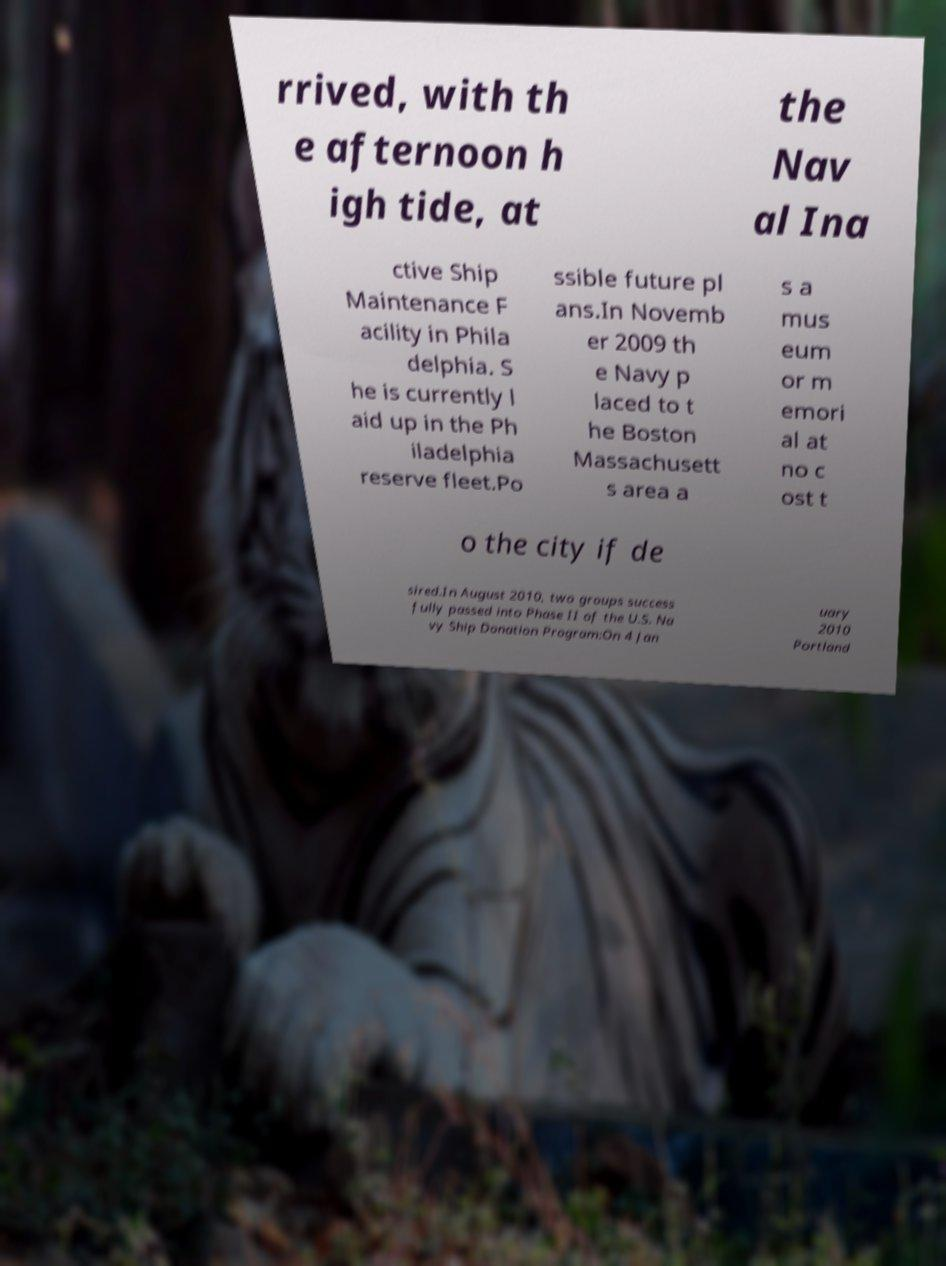I need the written content from this picture converted into text. Can you do that? rrived, with th e afternoon h igh tide, at the Nav al Ina ctive Ship Maintenance F acility in Phila delphia. S he is currently l aid up in the Ph iladelphia reserve fleet.Po ssible future pl ans.In Novemb er 2009 th e Navy p laced to t he Boston Massachusett s area a s a mus eum or m emori al at no c ost t o the city if de sired.In August 2010, two groups success fully passed into Phase II of the U.S. Na vy Ship Donation Program:On 4 Jan uary 2010 Portland 